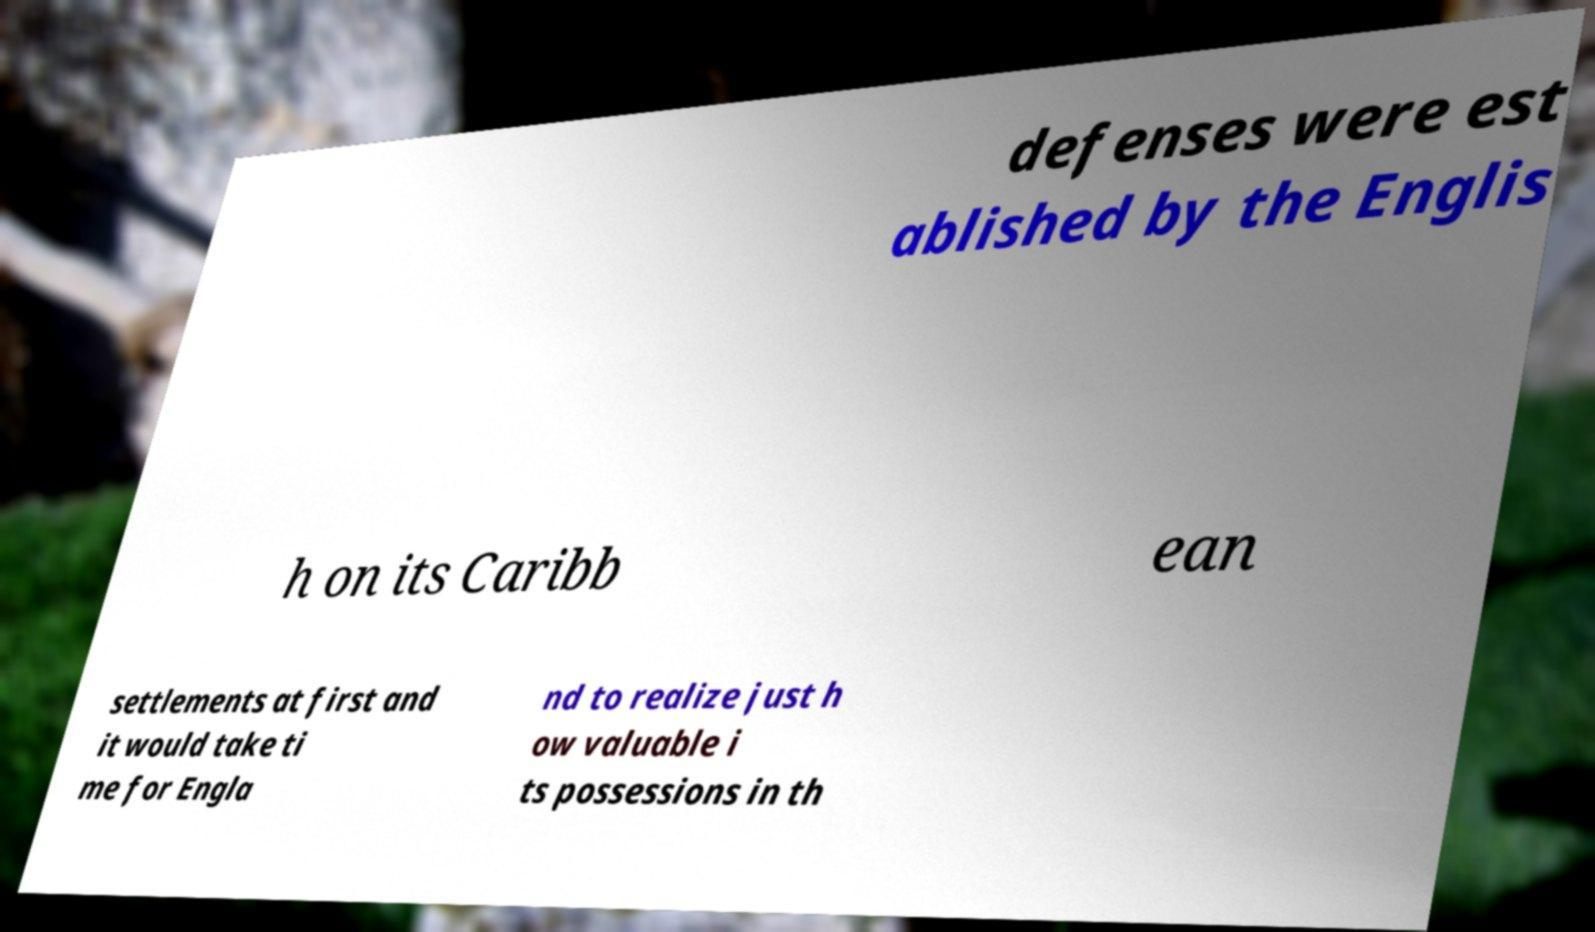There's text embedded in this image that I need extracted. Can you transcribe it verbatim? defenses were est ablished by the Englis h on its Caribb ean settlements at first and it would take ti me for Engla nd to realize just h ow valuable i ts possessions in th 